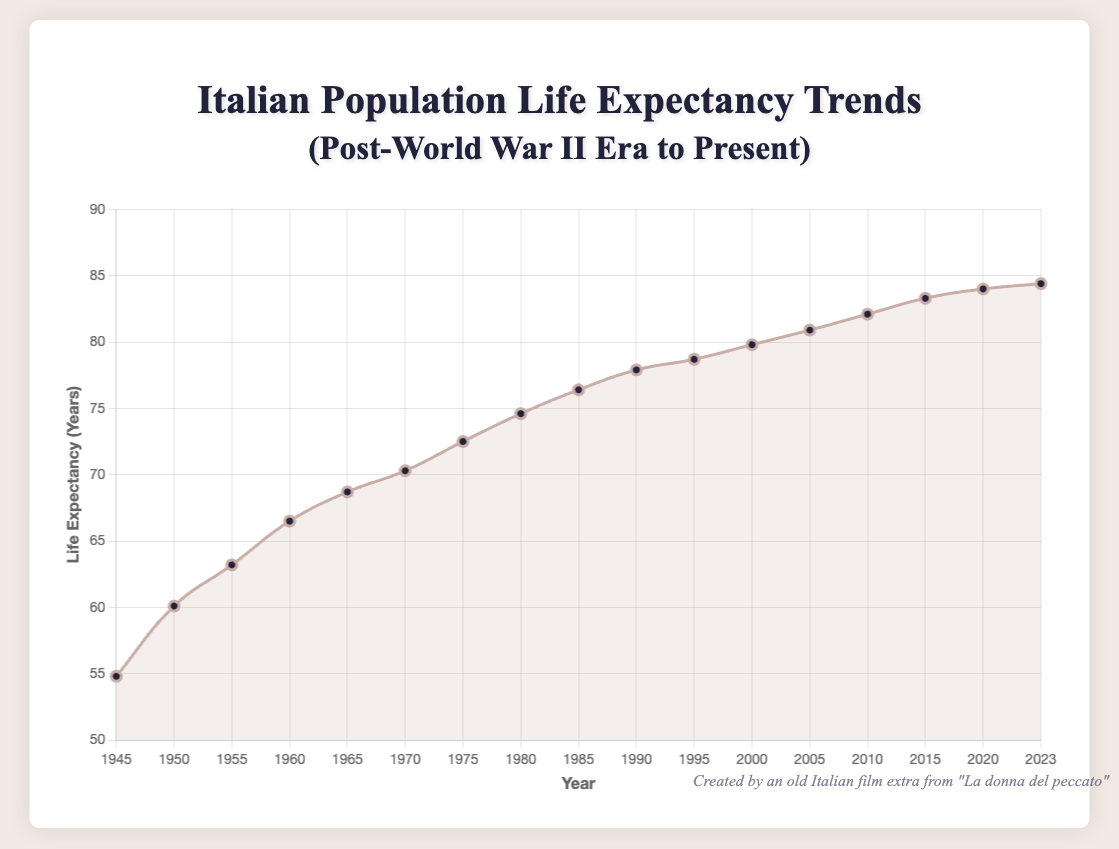Which year had the highest life expectancy? To find the year with the highest life expectancy, look at the y-values on the plot and identify the corresponding x-value (year). The highest life expectancy shown is 84.4 years in 2023.
Answer: 2023 What is the difference in life expectancy between 1950 and 2000? Find the life expectancy in 1950 and 2000 on the plot. Subtract the life expectancy of 1950 (60.1) from that of 2000 (79.8) to get the difference: 79.8 - 60.1 = 19.7 years.
Answer: 19.7 years Did the life expectancy increase more rapidly from 1945 to 1955 or from 1995 to 2005? Calculate the difference in life expectancy from 1945 to 1955: 63.2 - 54.8 = 8.4 years. For 1995 to 2005, the difference is 80.9 - 78.7 = 2.2 years. Compare these differences to see which period had a more rapid increase. The increase was greater from 1945 to 1955 (8.4 years).
Answer: 1945 to 1955 Does the life expectancy trend show any decrease in any period? Examine the plot for any downward slope in the curve. There is no period in the plot where life expectancy decreases, indicating a consistent upward trend.
Answer: No How many years did it take for life expectancy to increase from 70 to 80 years? Identify when the life expectancy was 70 years (1970) and when it reached 80 years (2005) on the plot. The difference in years is 2005 - 1970 = 35 years.
Answer: 35 years What is the average life expectancy from 1965 to 1975? Find the life expectancy values for each year between 1965 and 1975: 68.7, 70.3, and 72.5. Add these values and divide by the number of years to find the average: (68.7 + 70.3 + 72.5) / 3 = 70.5 years.
Answer: 70.5 years How does the rate of increase in life expectancy from 1980 to 1990 compare with the rate from 2010 to 2020? Calculate the difference in life expectancy from 1980 to 1990: 77.9 - 74.6 = 3.3 years over 10 years, so the rate is 0.33 years per year. For 2010 to 2020: 84.0 - 82.1 = 1.9 years over 10 years, so the rate is 0.19 years per year. The rate from 1980 to 1990 was higher (0.33 years per year versus 0.19 years per year).
Answer: 1980 to 1990 Which decade saw the smallest increase in life expectancy? Look at the life expectancy values at the start and end of each decade to calculate the difference. The decade with the smallest increase is 2010 to 2020, with an increase of 84.0 - 82.1 = 1.9 years.
Answer: 2010 to 2020 What visual features indicate the trend of increasing life expectancy? Observe the smooth upward curve of the plot line, the increasing y-values, and the positioning of data points which show a clear gradual upward movement over the years.
Answer: Upward curve and increasing values 